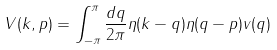<formula> <loc_0><loc_0><loc_500><loc_500>V ( k , p ) = \int _ { - \pi } ^ { \pi } \frac { d q } { 2 \pi } \eta ( k - q ) \eta ( q - p ) v ( q )</formula> 